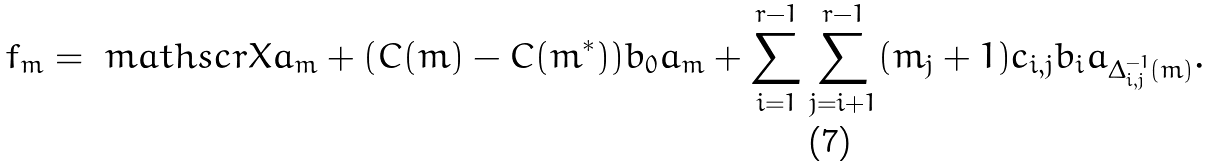Convert formula to latex. <formula><loc_0><loc_0><loc_500><loc_500>f _ { m } = \ m a t h s c r { X } a _ { m } + ( C ( { m } ) - C ( { m ^ { * } } ) ) b _ { 0 } a _ { m } + \sum _ { i = 1 } ^ { r - 1 } \sum _ { j = i + 1 } ^ { r - 1 } ( m _ { j } + 1 ) c _ { i , j } b _ { i } a _ { { \Delta _ { i , j } ^ { - 1 } } ( m ) } .</formula> 